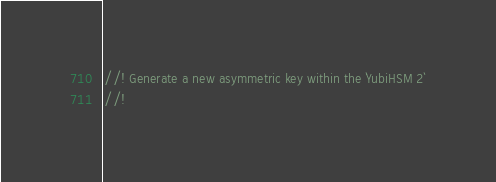<code> <loc_0><loc_0><loc_500><loc_500><_Rust_>//! Generate a new asymmetric key within the `YubiHSM 2`
//!</code> 